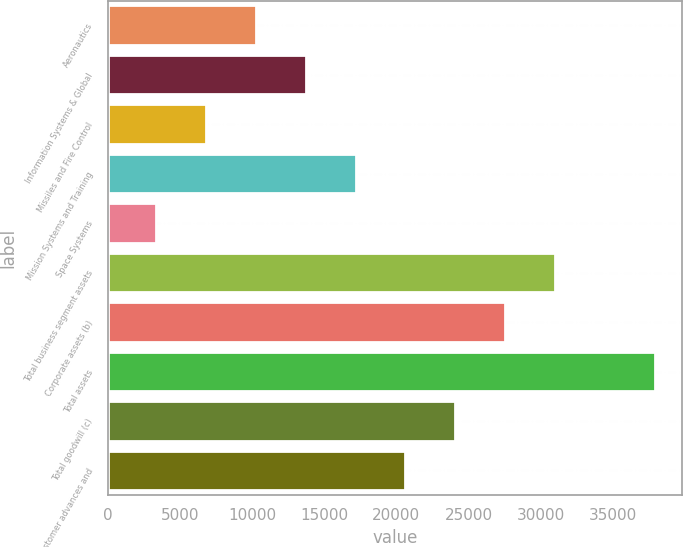<chart> <loc_0><loc_0><loc_500><loc_500><bar_chart><fcel>Aeronautics<fcel>Information Systems & Global<fcel>Missiles and Fire Control<fcel>Mission Systems and Training<fcel>Space Systems<fcel>Total business segment assets<fcel>Corporate assets (b)<fcel>Total assets<fcel>Total goodwill (c)<fcel>Total customer advances and<nl><fcel>10258.4<fcel>13714.6<fcel>6802.2<fcel>17170.8<fcel>3346<fcel>30995.6<fcel>27539.4<fcel>37908<fcel>24083.2<fcel>20627<nl></chart> 